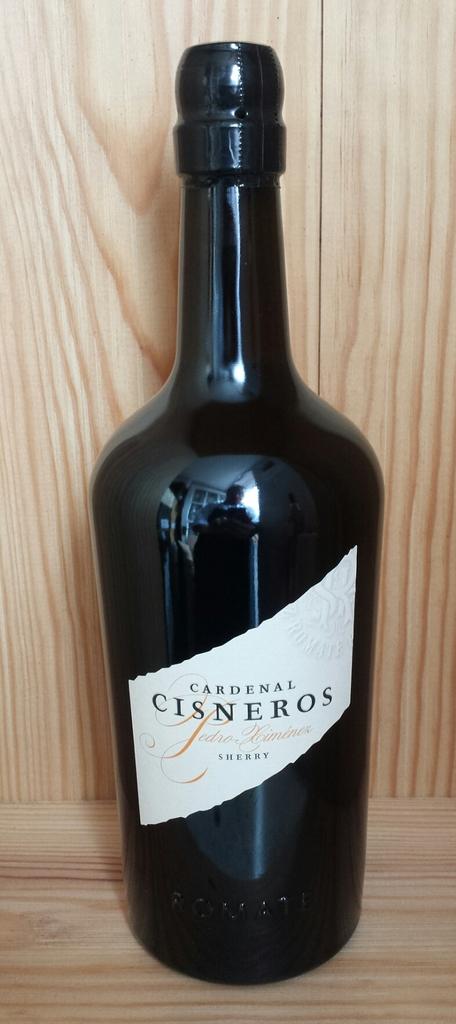What type of wine is this?
Make the answer very short. Sherry. 